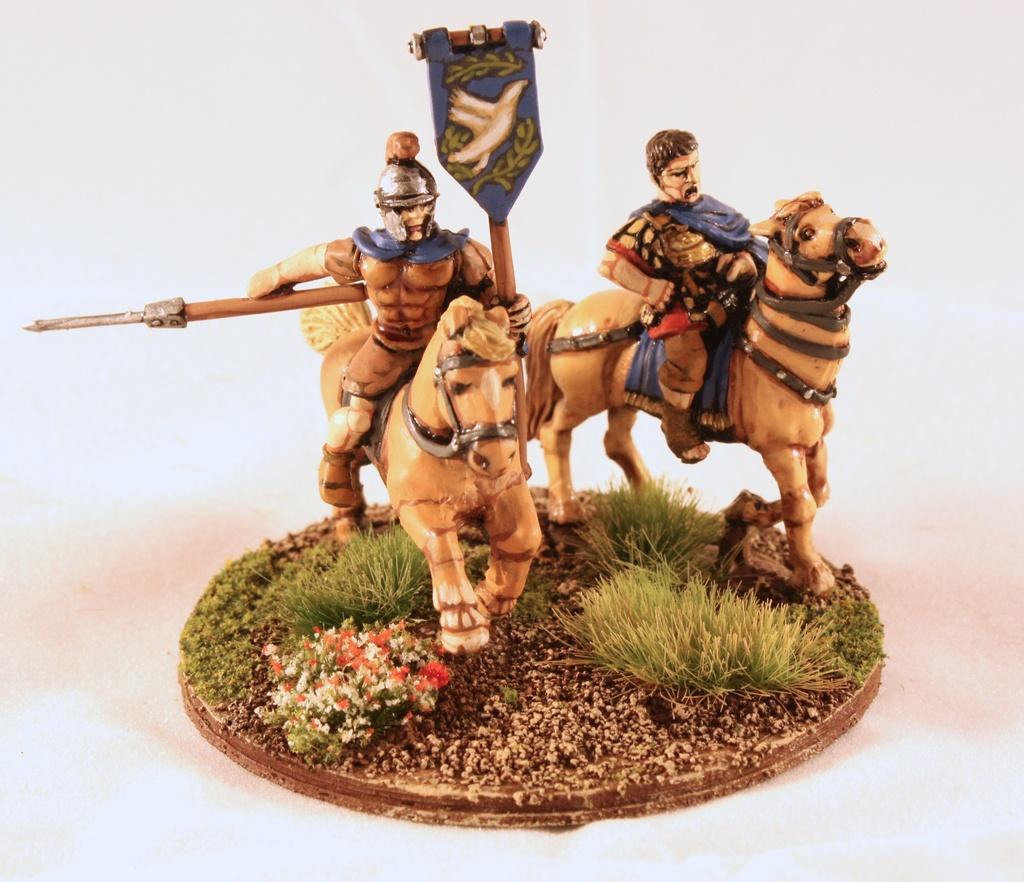In one or two sentences, can you explain what this image depicts? In this image we can see a statue and a white background. 